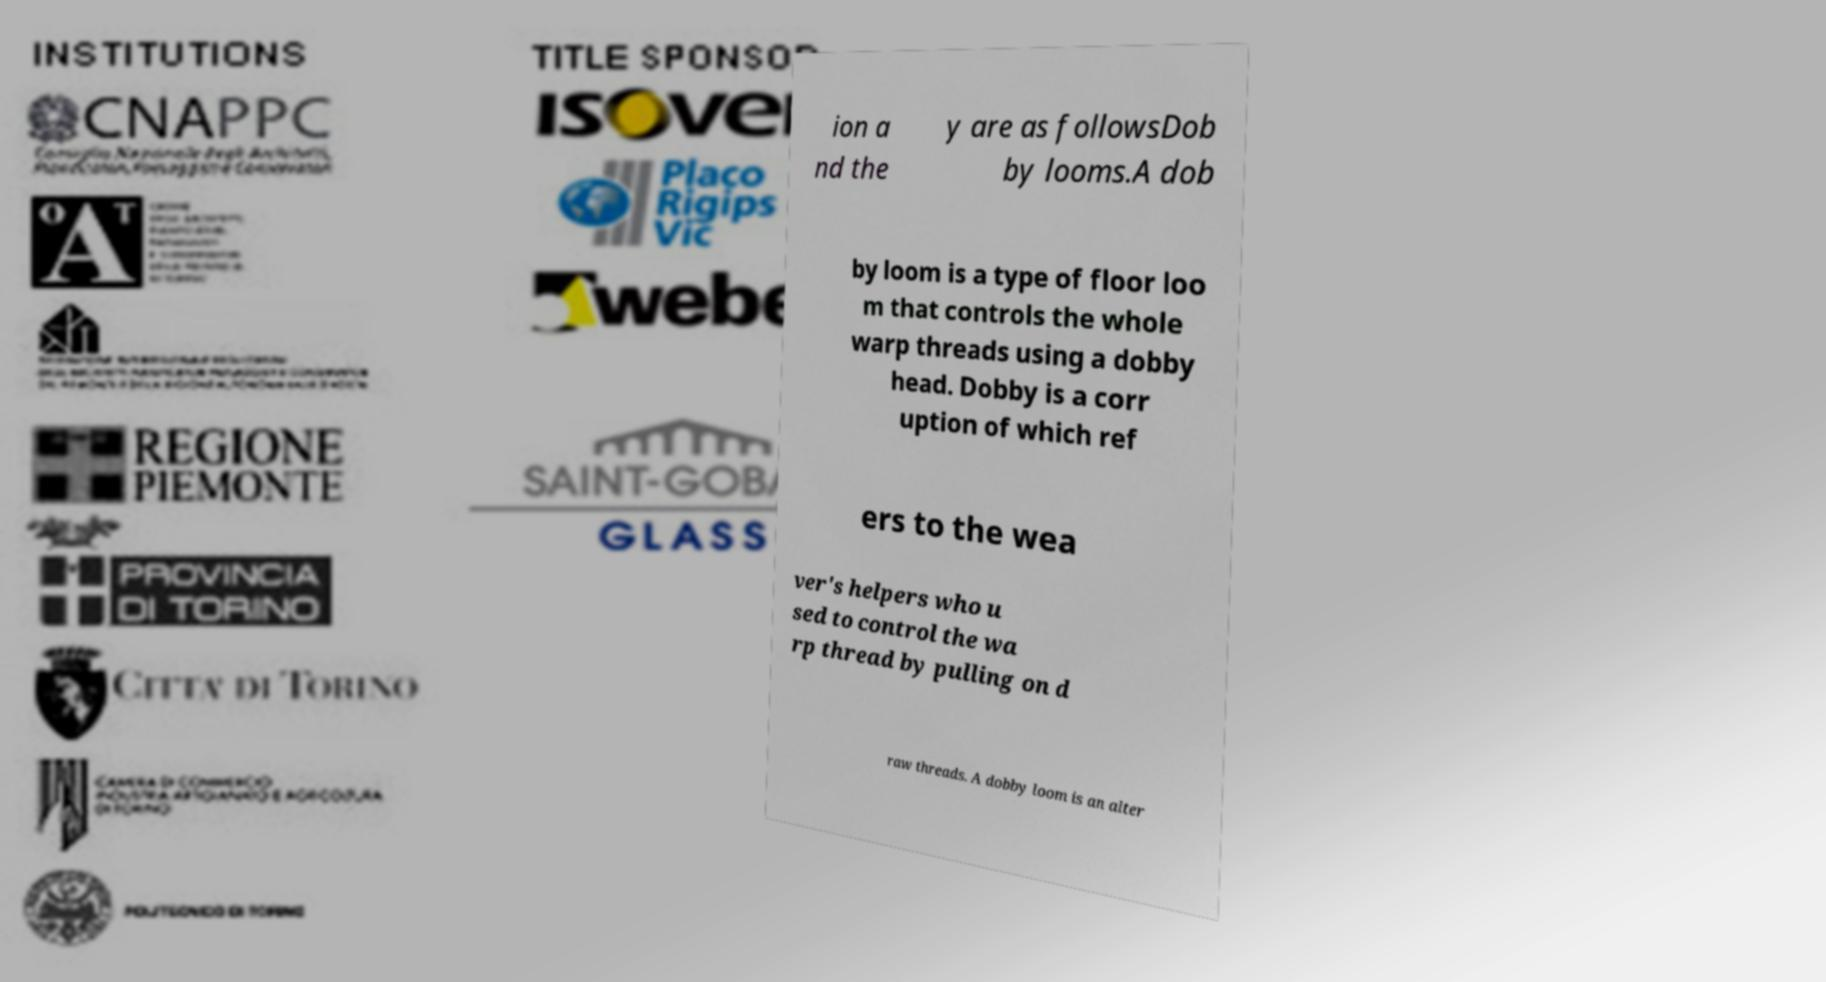For documentation purposes, I need the text within this image transcribed. Could you provide that? ion a nd the y are as followsDob by looms.A dob by loom is a type of floor loo m that controls the whole warp threads using a dobby head. Dobby is a corr uption of which ref ers to the wea ver's helpers who u sed to control the wa rp thread by pulling on d raw threads. A dobby loom is an alter 